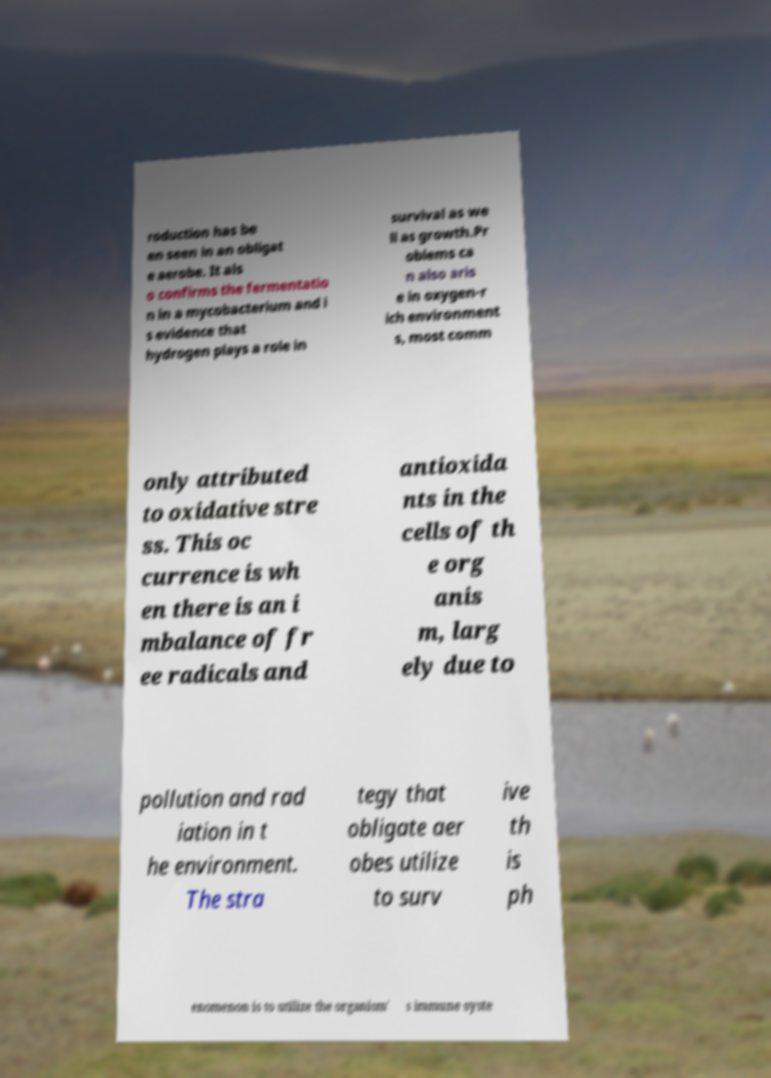Please identify and transcribe the text found in this image. roduction has be en seen in an obligat e aerobe. It als o confirms the fermentatio n in a mycobacterium and i s evidence that hydrogen plays a role in survival as we ll as growth.Pr oblems ca n also aris e in oxygen-r ich environment s, most comm only attributed to oxidative stre ss. This oc currence is wh en there is an i mbalance of fr ee radicals and antioxida nts in the cells of th e org anis m, larg ely due to pollution and rad iation in t he environment. The stra tegy that obligate aer obes utilize to surv ive th is ph enomenon is to utilize the organism' s immune syste 